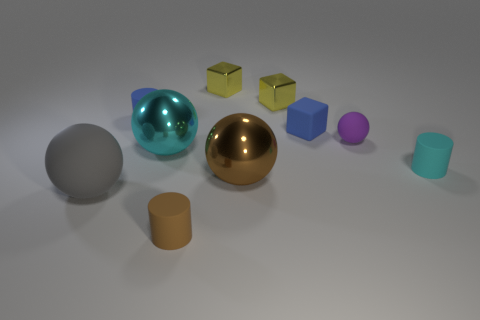Subtract all purple balls. How many balls are left? 3 Subtract all gray spheres. How many spheres are left? 3 Subtract 1 balls. How many balls are left? 3 Subtract all yellow cylinders. Subtract all green cubes. How many cylinders are left? 3 Subtract all blue cylinders. How many cyan balls are left? 1 Subtract all red metallic spheres. Subtract all small matte cylinders. How many objects are left? 7 Add 4 brown cylinders. How many brown cylinders are left? 5 Add 5 cyan matte spheres. How many cyan matte spheres exist? 5 Subtract 0 yellow balls. How many objects are left? 10 Subtract all balls. How many objects are left? 6 